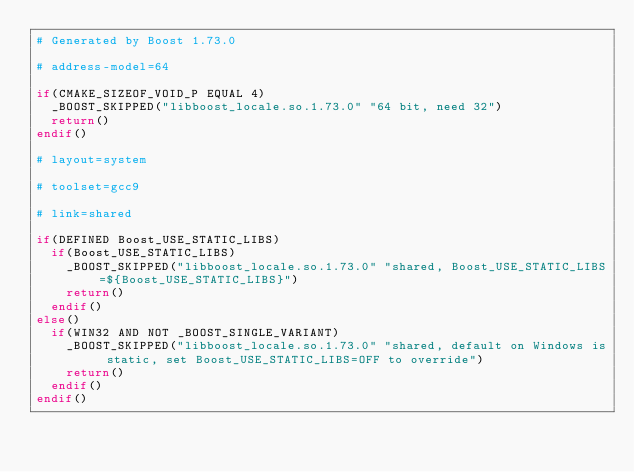<code> <loc_0><loc_0><loc_500><loc_500><_CMake_># Generated by Boost 1.73.0

# address-model=64

if(CMAKE_SIZEOF_VOID_P EQUAL 4)
  _BOOST_SKIPPED("libboost_locale.so.1.73.0" "64 bit, need 32")
  return()
endif()

# layout=system

# toolset=gcc9

# link=shared

if(DEFINED Boost_USE_STATIC_LIBS)
  if(Boost_USE_STATIC_LIBS)
    _BOOST_SKIPPED("libboost_locale.so.1.73.0" "shared, Boost_USE_STATIC_LIBS=${Boost_USE_STATIC_LIBS}")
    return()
  endif()
else()
  if(WIN32 AND NOT _BOOST_SINGLE_VARIANT)
    _BOOST_SKIPPED("libboost_locale.so.1.73.0" "shared, default on Windows is static, set Boost_USE_STATIC_LIBS=OFF to override")
    return()
  endif()
endif()
</code> 